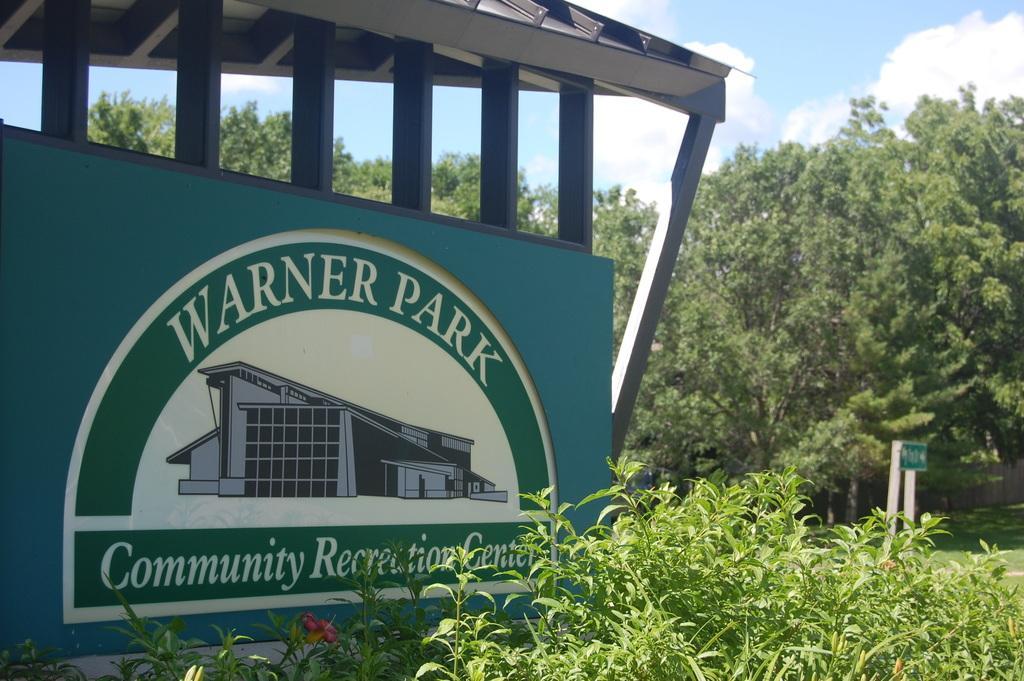Could you give a brief overview of what you see in this image? In this picture I can see a board in front on which there is something written and I see the depiction of a building on it and I see plants in front of the board. In the background I see the trees and the sky. 